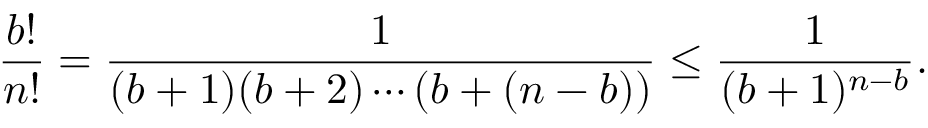Convert formula to latex. <formula><loc_0><loc_0><loc_500><loc_500>{ \frac { b ! } { n ! } } = { \frac { 1 } { ( b + 1 ) ( b + 2 ) \cdots ( b + ( n - b ) ) } } \leq { \frac { 1 } { ( b + 1 ) ^ { n - b } } } .</formula> 